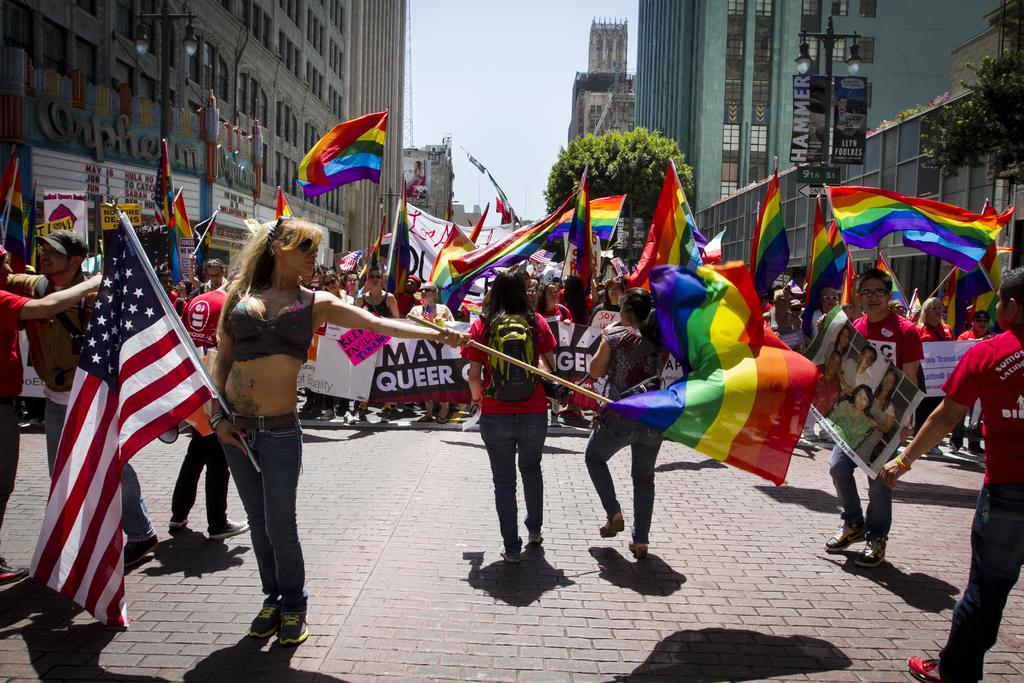What are the people in the image doing? The people in the image are standing and holding flags and posters. What else can be seen in the image besides the people? There are buildings, a green tree, and the sky visible in the image. Who is the creator of the base in the image? There is no base present in the image, so it is not possible to determine who its creator might be. 